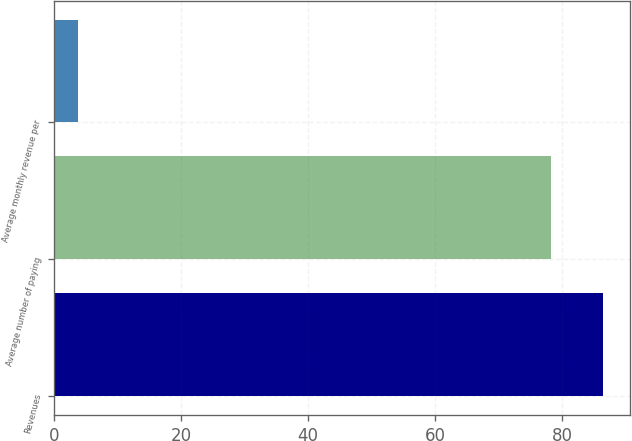<chart> <loc_0><loc_0><loc_500><loc_500><bar_chart><fcel>Revenues<fcel>Average number of paying<fcel>Average monthly revenue per<nl><fcel>86.43<fcel>78.3<fcel>3.8<nl></chart> 